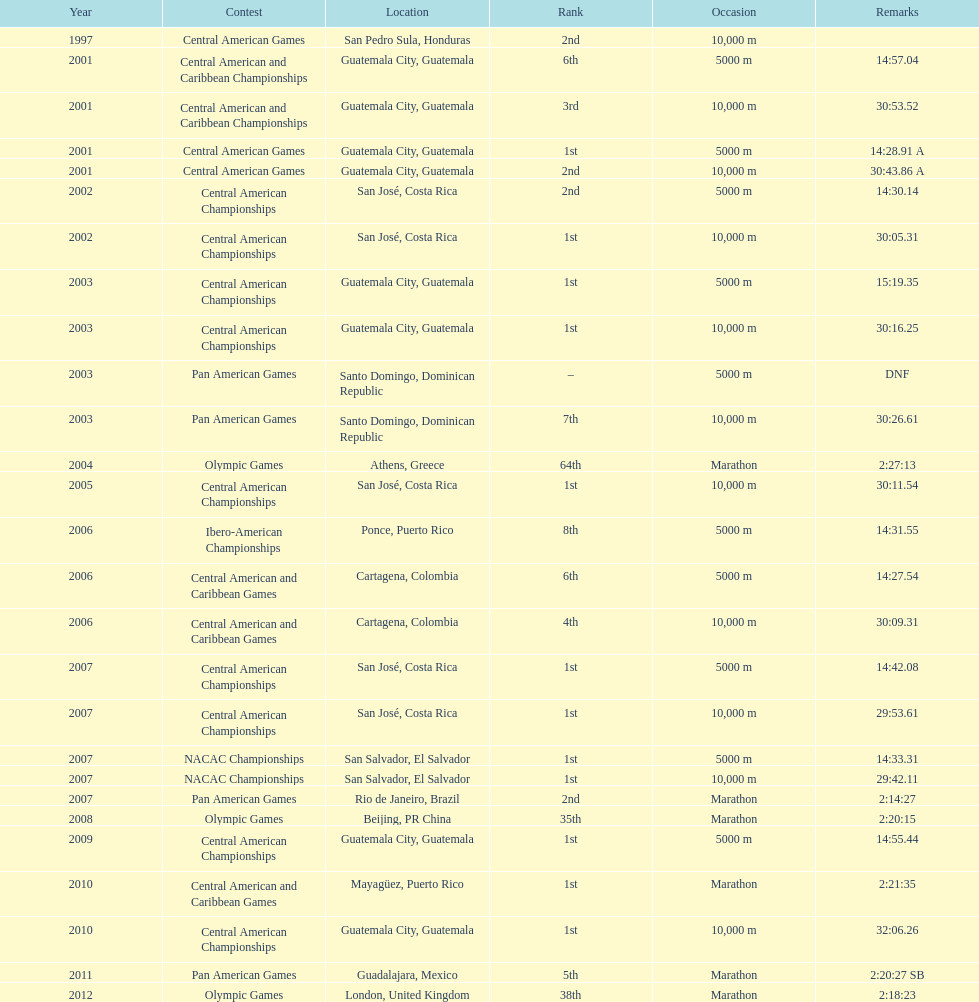Which of each game in 2007 was in the 2nd position? Pan American Games. 